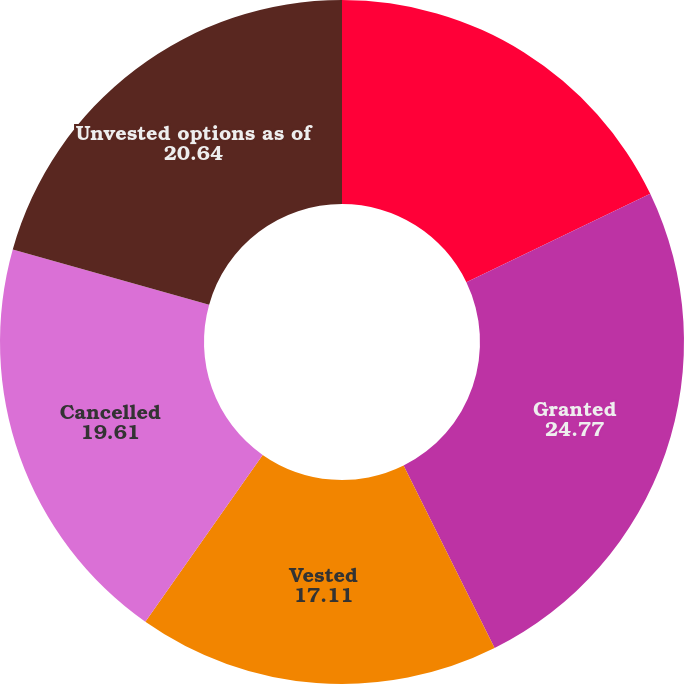<chart> <loc_0><loc_0><loc_500><loc_500><pie_chart><fcel>Unvested options as of January<fcel>Granted<fcel>Vested<fcel>Cancelled<fcel>Unvested options as of<nl><fcel>17.87%<fcel>24.77%<fcel>17.11%<fcel>19.61%<fcel>20.64%<nl></chart> 